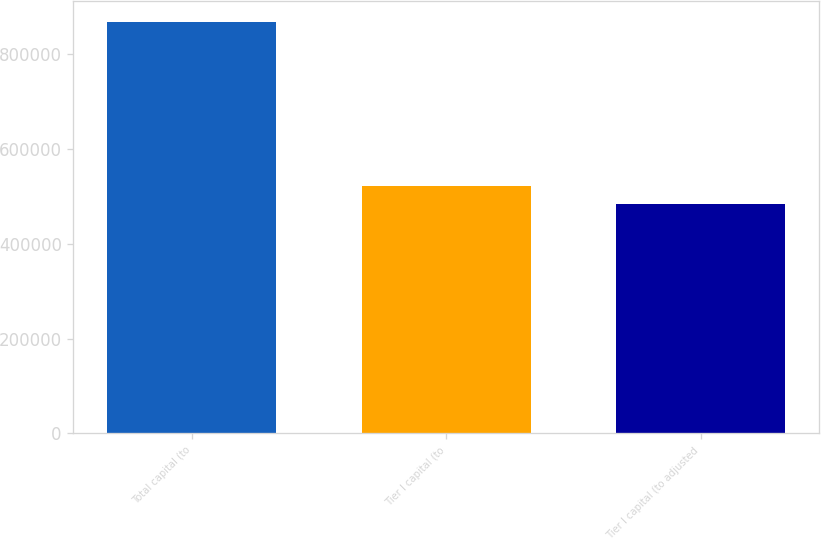Convert chart to OTSL. <chart><loc_0><loc_0><loc_500><loc_500><bar_chart><fcel>Total capital (to<fcel>Tier I capital (to<fcel>Tier I capital (to adjusted<nl><fcel>867844<fcel>521311<fcel>482807<nl></chart> 